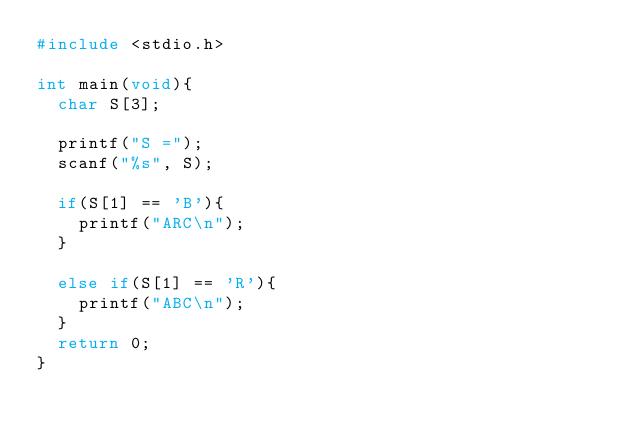<code> <loc_0><loc_0><loc_500><loc_500><_C_>#include <stdio.h>

int main(void){
  char S[3];
  
  printf("S =");
  scanf("%s", S);
  
  if(S[1] == 'B'){
    printf("ARC\n");
  }
  
  else if(S[1] == 'R'){
    printf("ABC\n");
  }
  return 0;
}</code> 